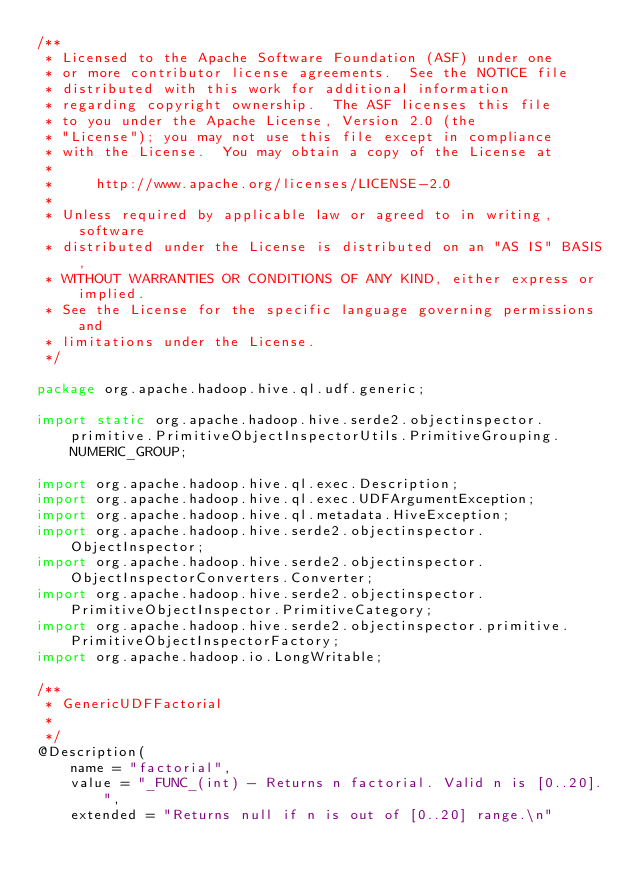Convert code to text. <code><loc_0><loc_0><loc_500><loc_500><_Java_>/**
 * Licensed to the Apache Software Foundation (ASF) under one
 * or more contributor license agreements.  See the NOTICE file
 * distributed with this work for additional information
 * regarding copyright ownership.  The ASF licenses this file
 * to you under the Apache License, Version 2.0 (the
 * "License"); you may not use this file except in compliance
 * with the License.  You may obtain a copy of the License at
 *
 *     http://www.apache.org/licenses/LICENSE-2.0
 *
 * Unless required by applicable law or agreed to in writing, software
 * distributed under the License is distributed on an "AS IS" BASIS,
 * WITHOUT WARRANTIES OR CONDITIONS OF ANY KIND, either express or implied.
 * See the License for the specific language governing permissions and
 * limitations under the License.
 */

package org.apache.hadoop.hive.ql.udf.generic;

import static org.apache.hadoop.hive.serde2.objectinspector.primitive.PrimitiveObjectInspectorUtils.PrimitiveGrouping.NUMERIC_GROUP;

import org.apache.hadoop.hive.ql.exec.Description;
import org.apache.hadoop.hive.ql.exec.UDFArgumentException;
import org.apache.hadoop.hive.ql.metadata.HiveException;
import org.apache.hadoop.hive.serde2.objectinspector.ObjectInspector;
import org.apache.hadoop.hive.serde2.objectinspector.ObjectInspectorConverters.Converter;
import org.apache.hadoop.hive.serde2.objectinspector.PrimitiveObjectInspector.PrimitiveCategory;
import org.apache.hadoop.hive.serde2.objectinspector.primitive.PrimitiveObjectInspectorFactory;
import org.apache.hadoop.io.LongWritable;

/**
 * GenericUDFFactorial
 *
 */
@Description(
    name = "factorial",
    value = "_FUNC_(int) - Returns n factorial. Valid n is [0..20].",
    extended = "Returns null if n is out of [0..20] range.\n"</code> 